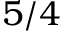Convert formula to latex. <formula><loc_0><loc_0><loc_500><loc_500>5 / 4</formula> 